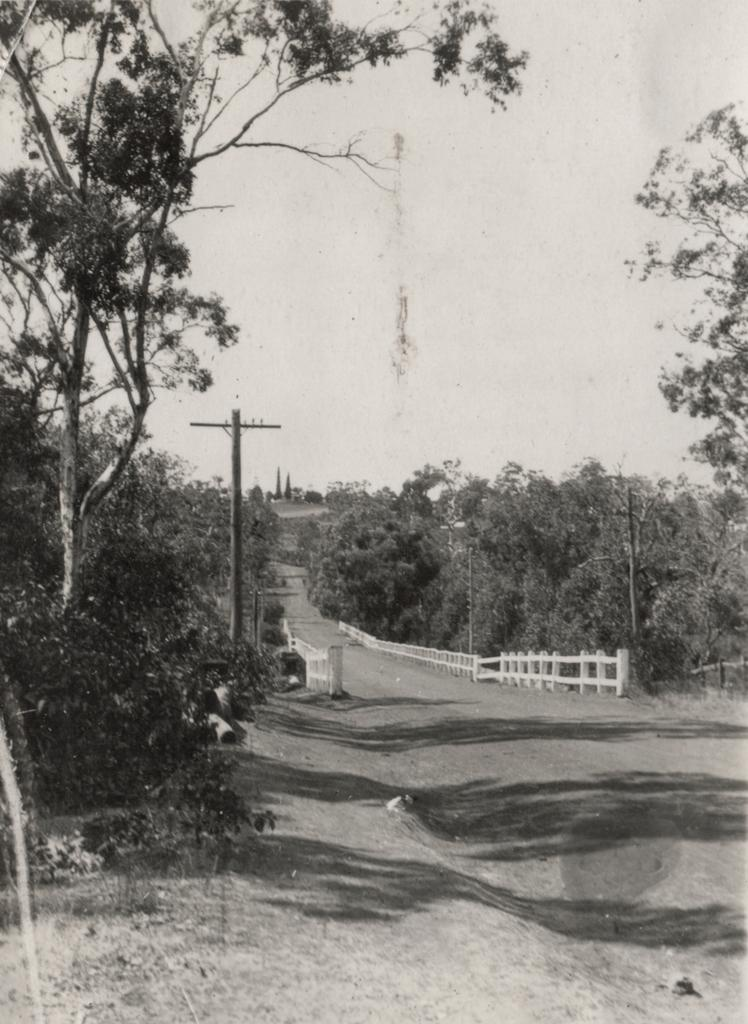What is the color scheme of the image? The image is black and white. What type of natural elements can be seen in the image? There are trees in the image. What man-made structures are present in the image? Electrical poles are present in the image. What type of man-made path is visible in the image? There is a road in the image. What objects are used to separate or control traffic in the image? Barriers are visible in the image. What part of the natural environment is visible in the image? The sky is visible in the image. What day of the week is it in the image? The image does not provide any information about the day of the week. Can you tell me what the people in the image are talking about? There are no people visible in the image, so it is impossible to determine what they might be talking about. 